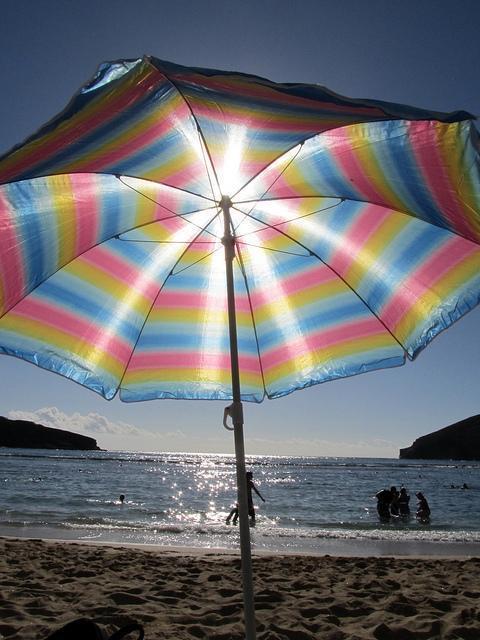What is planted in the sand?
From the following set of four choices, select the accurate answer to respond to the question.
Options: Net, tent, flag, umbrella. Umbrella. 